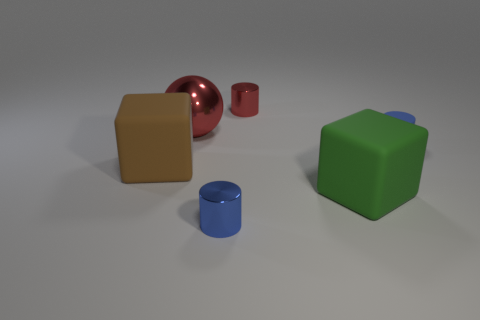Add 3 big matte cubes. How many objects exist? 9 Subtract all cubes. How many objects are left? 4 Subtract 0 yellow cubes. How many objects are left? 6 Subtract all green shiny spheres. Subtract all big brown objects. How many objects are left? 5 Add 1 rubber objects. How many rubber objects are left? 4 Add 3 green things. How many green things exist? 4 